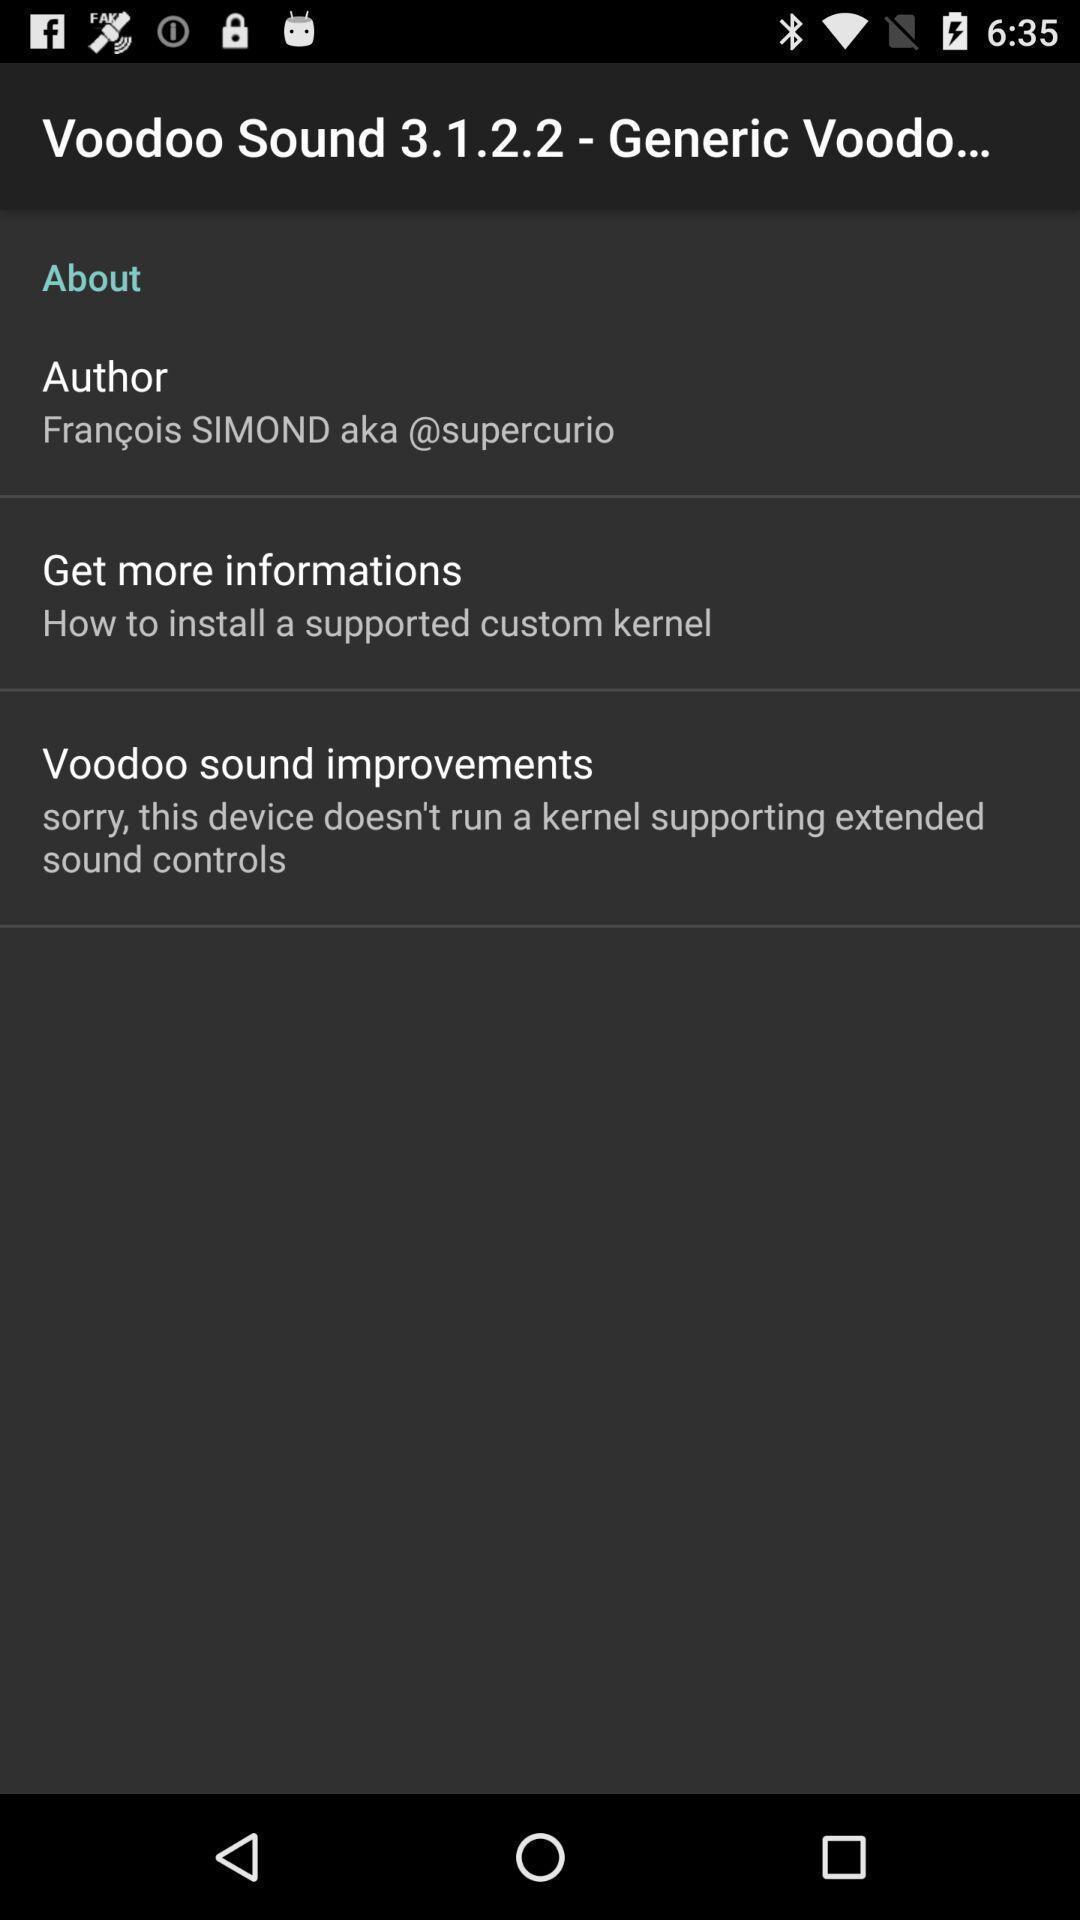What is the overall content of this screenshot? Screen shows other details. 